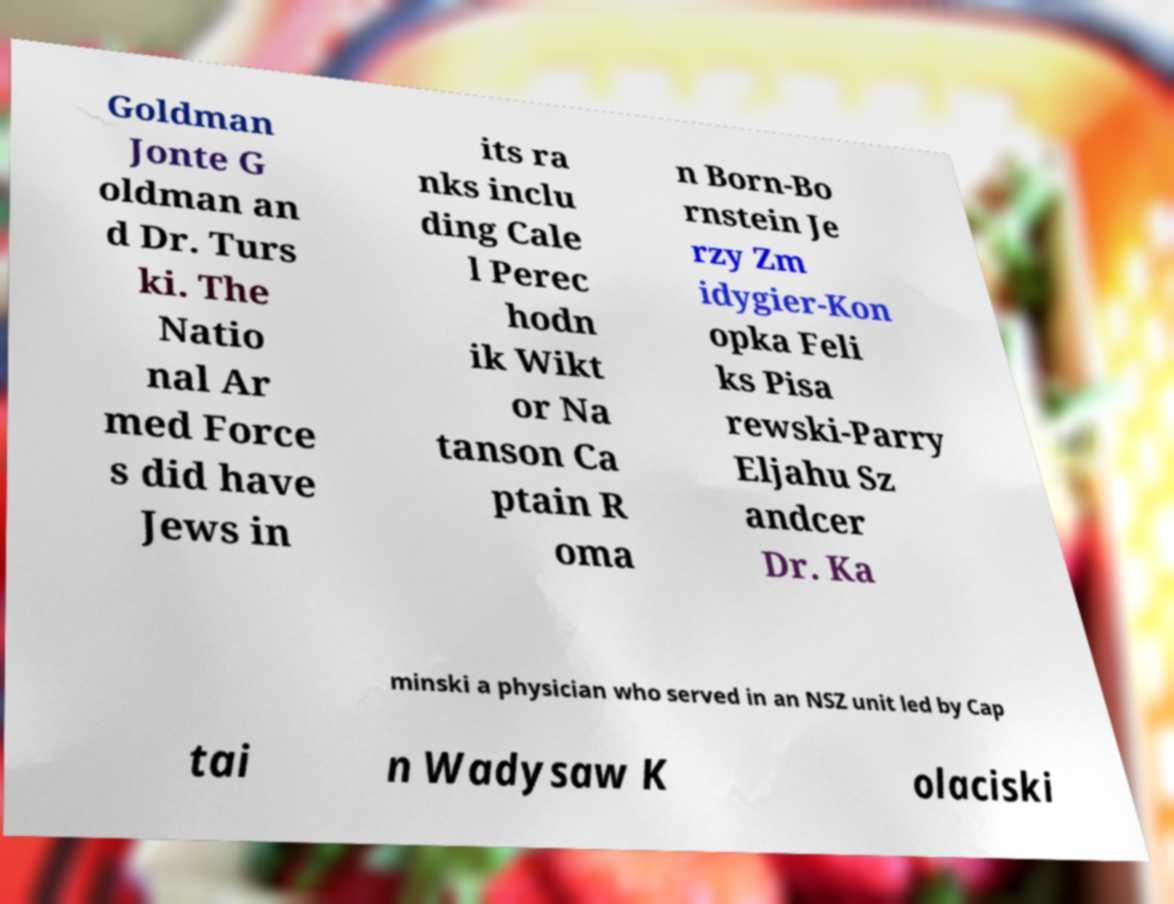Could you extract and type out the text from this image? Goldman Jonte G oldman an d Dr. Turs ki. The Natio nal Ar med Force s did have Jews in its ra nks inclu ding Cale l Perec hodn ik Wikt or Na tanson Ca ptain R oma n Born-Bo rnstein Je rzy Zm idygier-Kon opka Feli ks Pisa rewski-Parry Eljahu Sz andcer Dr. Ka minski a physician who served in an NSZ unit led by Cap tai n Wadysaw K olaciski 